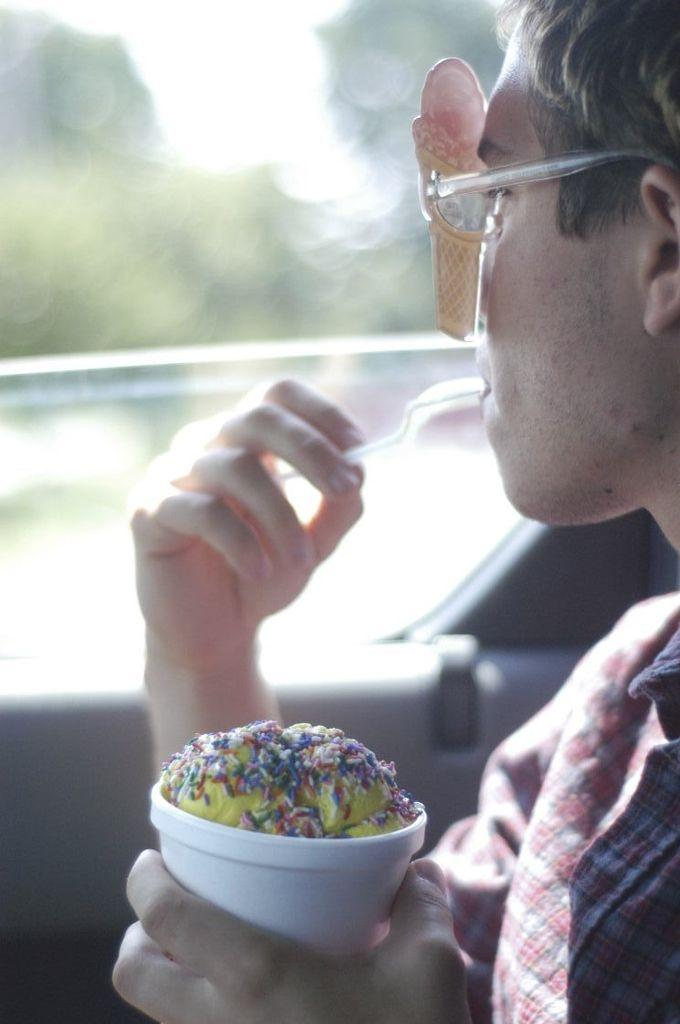Who is present in the image? There is a man in the picture. What is the man doing in the image? The man is seated. What can be seen on the man's face in the image? The man is wearing spectacles. What is the man holding in his hand in the image? The man is holding a cup in his hand. What can be seen in the distance in the image? There are trees visible in the background of the image. What type of guide is the man holding in the image? There is no guide present in the image; the man is holding a cup. How does the cub interact with the man in the image? There is no cub present in the image; it only features a man. 